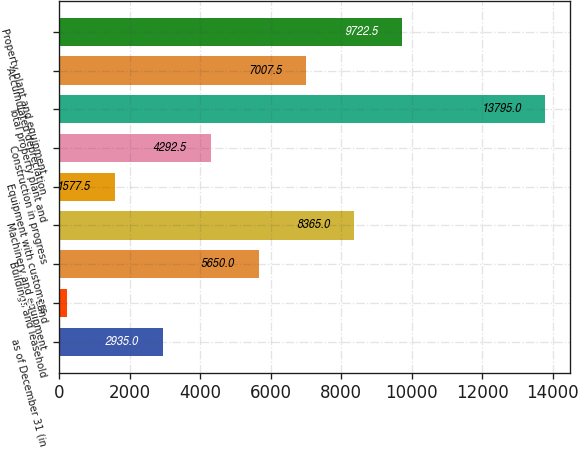Convert chart to OTSL. <chart><loc_0><loc_0><loc_500><loc_500><bar_chart><fcel>as of December 31 (in<fcel>Land<fcel>Buildings and leasehold<fcel>Machinery and equipment<fcel>Equipment with customers<fcel>Construction in progress<fcel>Total property plant and<fcel>Accumulated depreciation<fcel>Property plant and equipment<nl><fcel>2935<fcel>220<fcel>5650<fcel>8365<fcel>1577.5<fcel>4292.5<fcel>13795<fcel>7007.5<fcel>9722.5<nl></chart> 